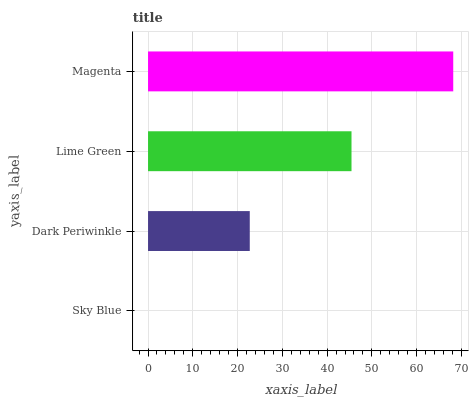Is Sky Blue the minimum?
Answer yes or no. Yes. Is Magenta the maximum?
Answer yes or no. Yes. Is Dark Periwinkle the minimum?
Answer yes or no. No. Is Dark Periwinkle the maximum?
Answer yes or no. No. Is Dark Periwinkle greater than Sky Blue?
Answer yes or no. Yes. Is Sky Blue less than Dark Periwinkle?
Answer yes or no. Yes. Is Sky Blue greater than Dark Periwinkle?
Answer yes or no. No. Is Dark Periwinkle less than Sky Blue?
Answer yes or no. No. Is Lime Green the high median?
Answer yes or no. Yes. Is Dark Periwinkle the low median?
Answer yes or no. Yes. Is Dark Periwinkle the high median?
Answer yes or no. No. Is Lime Green the low median?
Answer yes or no. No. 